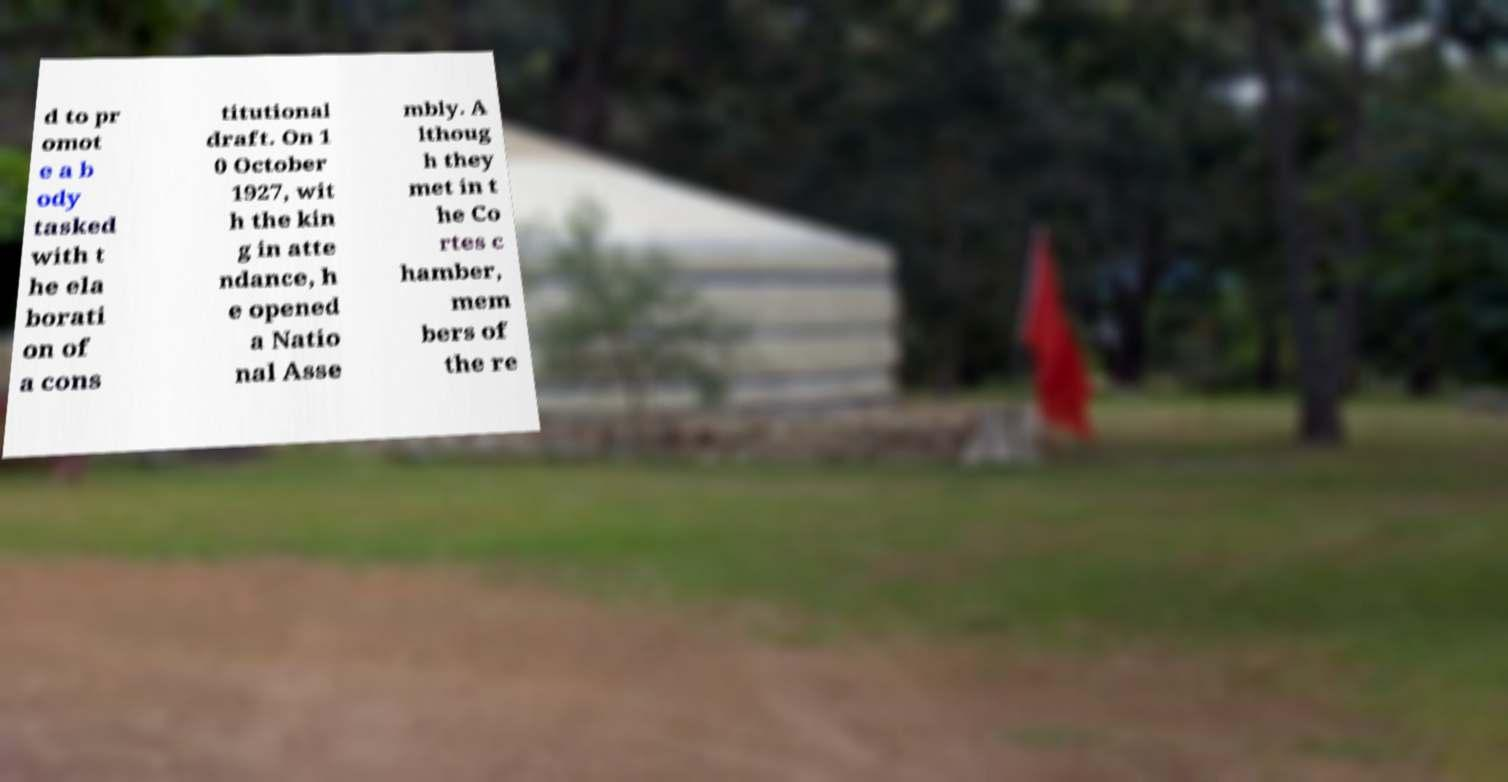I need the written content from this picture converted into text. Can you do that? d to pr omot e a b ody tasked with t he ela borati on of a cons titutional draft. On 1 0 October 1927, wit h the kin g in atte ndance, h e opened a Natio nal Asse mbly. A lthoug h they met in t he Co rtes c hamber, mem bers of the re 